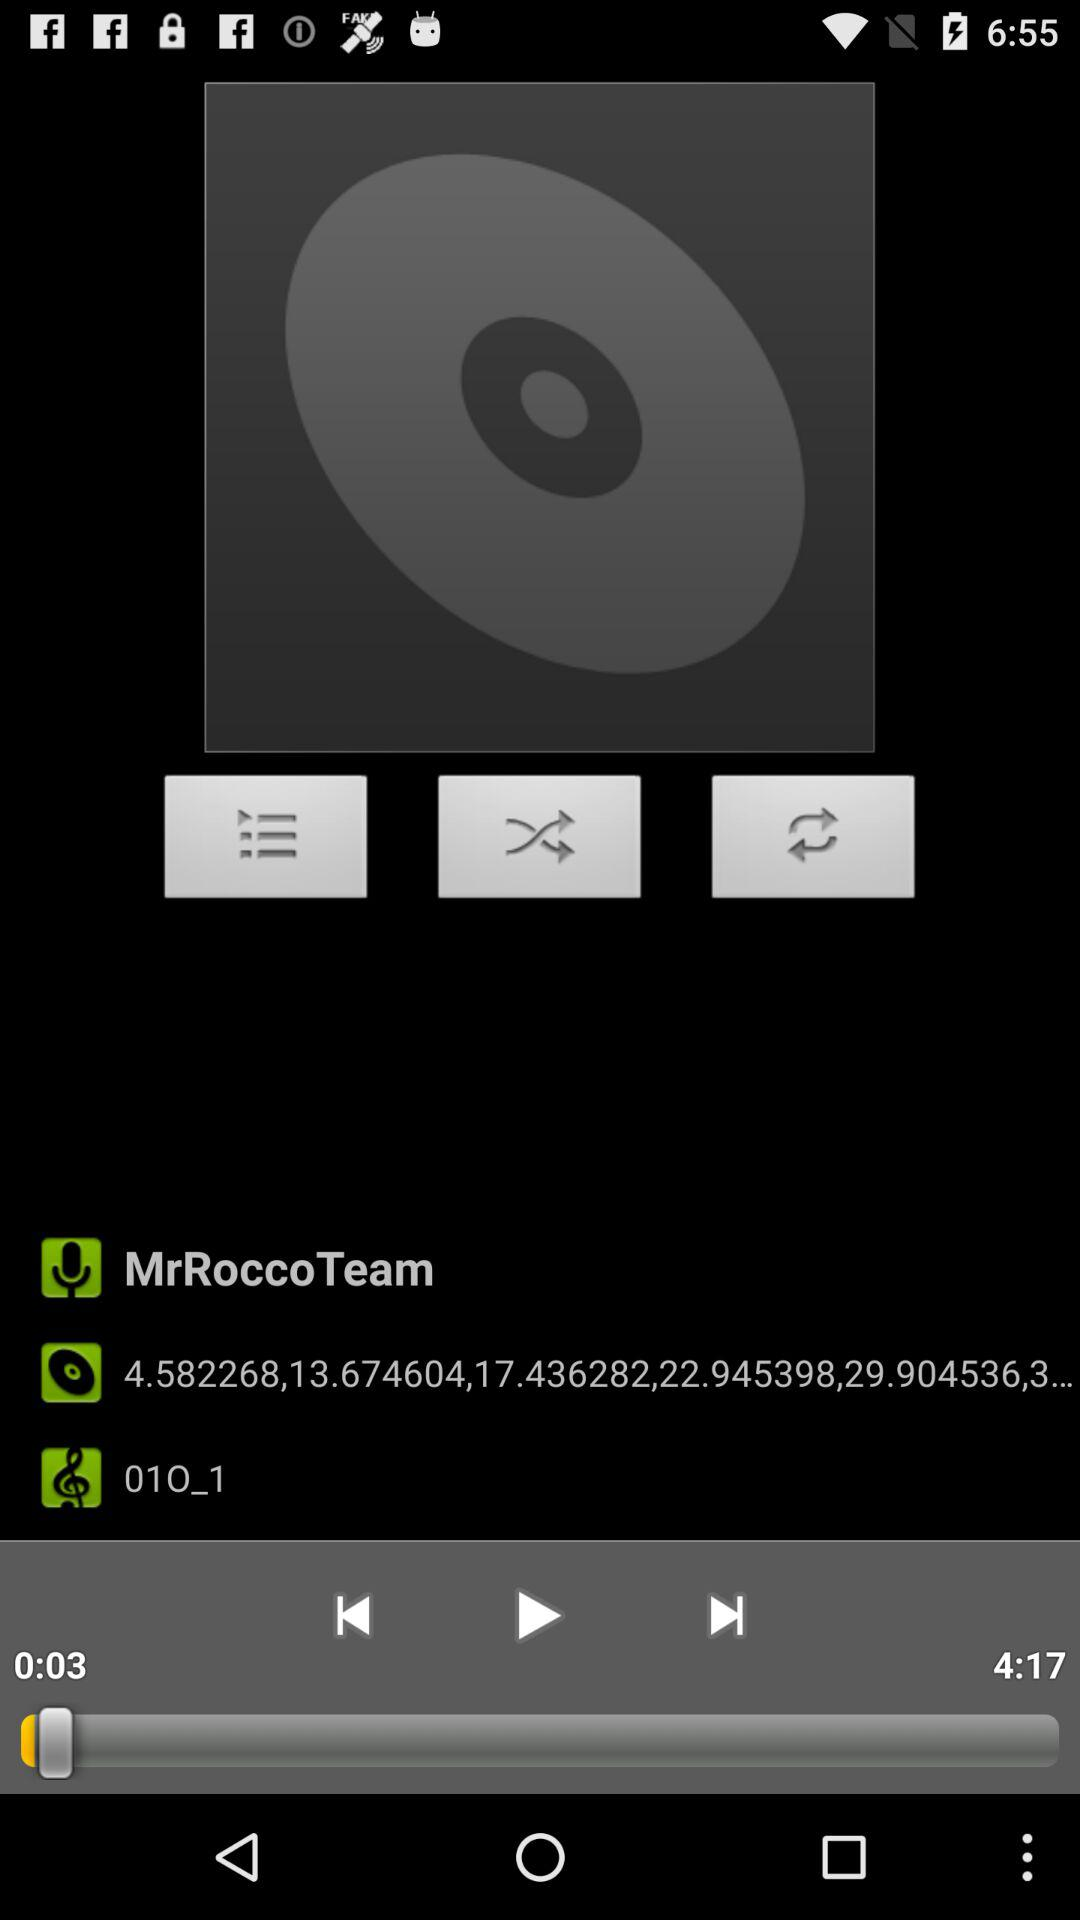Which song was last played? The song that was last played was "01O_1". 